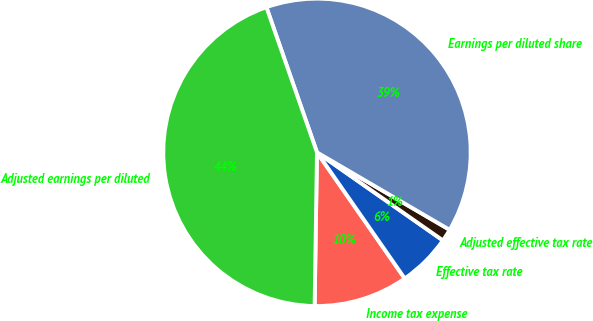Convert chart. <chart><loc_0><loc_0><loc_500><loc_500><pie_chart><fcel>Income tax expense<fcel>Effective tax rate<fcel>Adjusted effective tax rate<fcel>Earnings per diluted share<fcel>Adjusted earnings per diluted<nl><fcel>9.92%<fcel>5.61%<fcel>1.3%<fcel>38.75%<fcel>44.42%<nl></chart> 